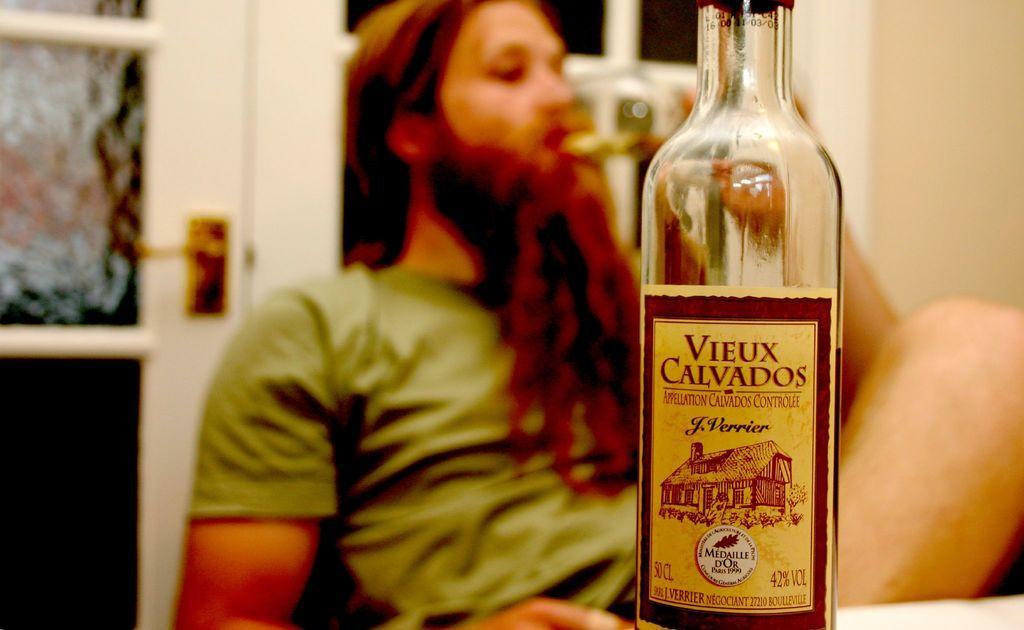How would you summarize this image in a sentence or two? This picture is clicked inside the room. In front of the picture, we see an alcohol bottle with some text written on it. Behind that, we see man in green t-shirt is holding glass in his hands and drinking liquid. Behind him, we see wall in white color and also windows. 